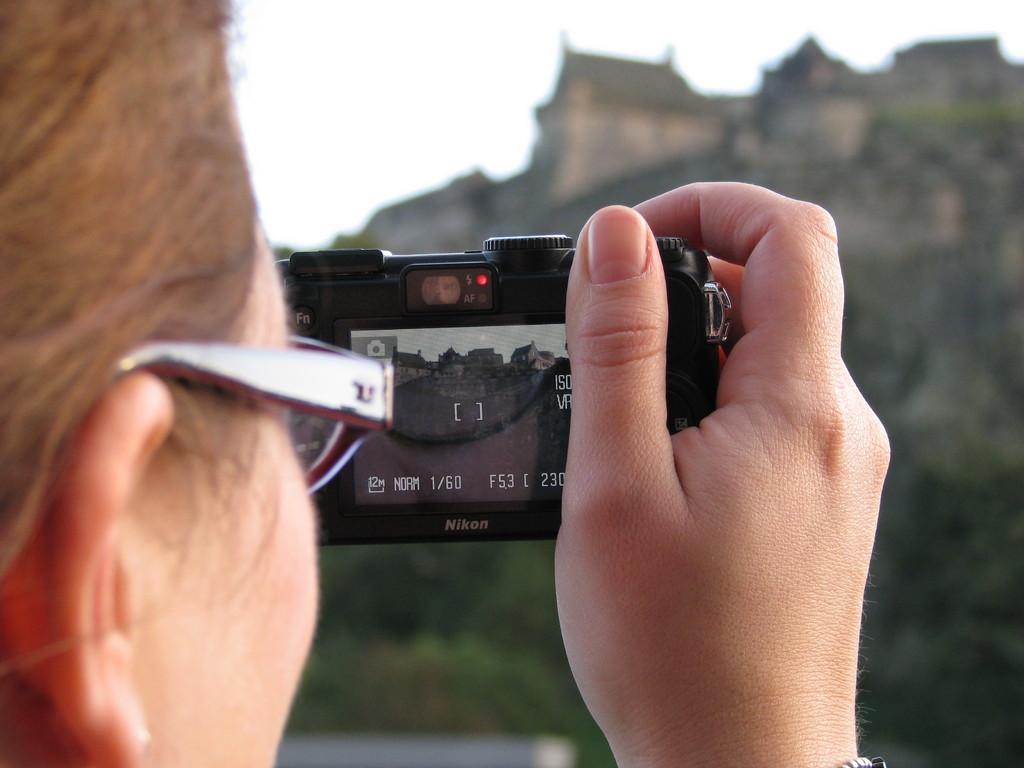In one or two sentences, can you explain what this image depicts? This is a person holding a camera and clicking the pictures. I think this is a spectacle. In the background, I think these are the buildings, which are at the top of a hill. 